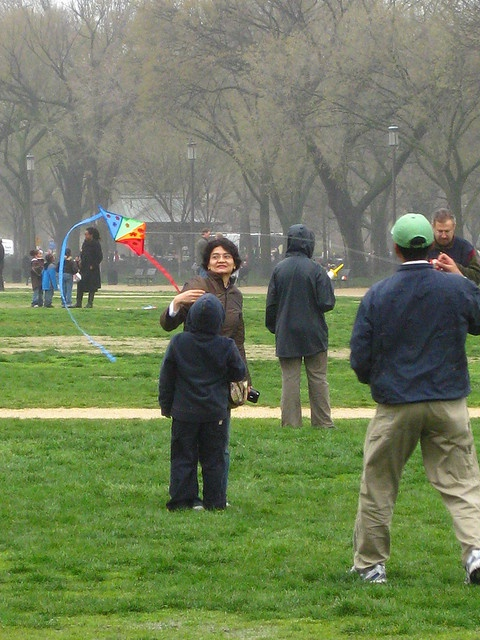Describe the objects in this image and their specific colors. I can see people in darkgray, black, gray, and darkgreen tones, people in darkgray, black, purple, and blue tones, people in darkgray, gray, black, and purple tones, people in darkgray, gray, and black tones, and kite in darkgray, lightblue, salmon, and beige tones in this image. 